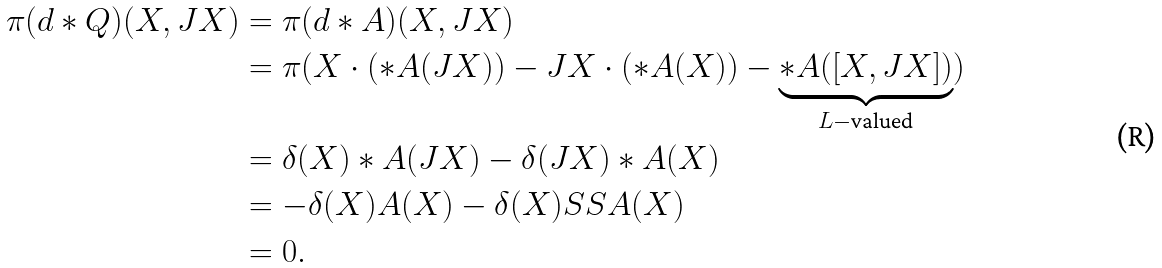<formula> <loc_0><loc_0><loc_500><loc_500>\pi ( d * Q ) ( X , J X ) & = \pi ( d * A ) ( X , J X ) \\ & = \pi ( X \cdot ( * A ( J X ) ) - J X \cdot ( * A ( X ) ) - \underbrace { * A ( [ X , J X ] ) } _ { L - \text {valued} } ) \\ & = \delta ( X ) * A ( J X ) - \delta ( J X ) * A ( X ) \\ & = - \delta ( X ) A ( X ) - \delta ( X ) S S A ( X ) \\ & = 0 .</formula> 